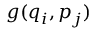<formula> <loc_0><loc_0><loc_500><loc_500>g ( q _ { i } , p _ { j } )</formula> 